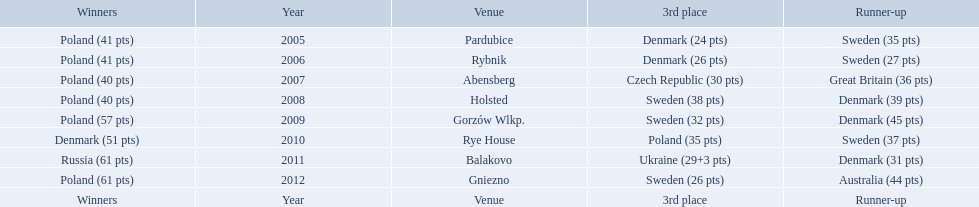In what years did denmark place in the top 3 in the team speedway junior world championship? 2005, 2006, 2008, 2009, 2010, 2011. What in what year did denmark come withing 2 points of placing higher in the standings? 2006. What place did denmark receive the year they missed higher ranking by only 2 points? 3rd place. 